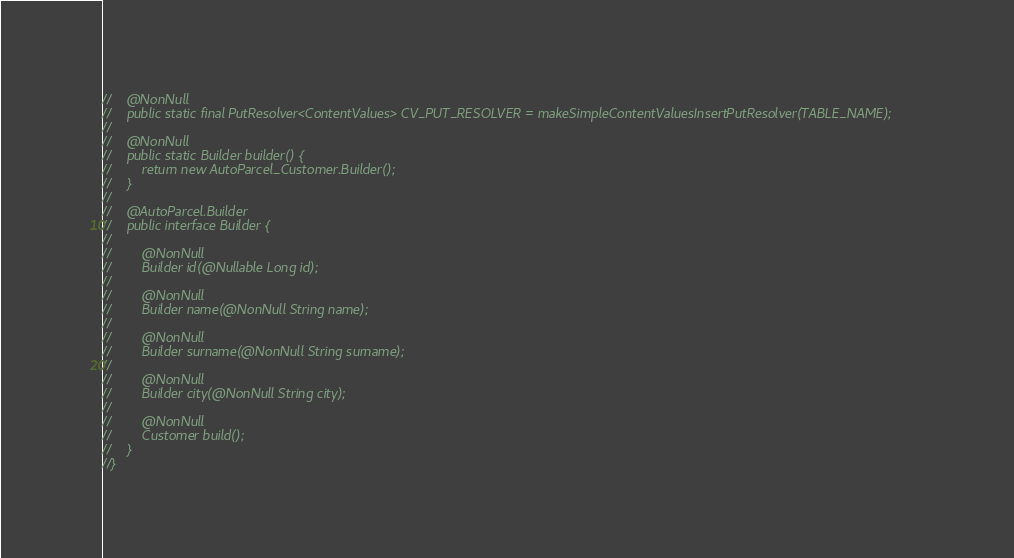Convert code to text. <code><loc_0><loc_0><loc_500><loc_500><_Java_>//    @NonNull
//    public static final PutResolver<ContentValues> CV_PUT_RESOLVER = makeSimpleContentValuesInsertPutResolver(TABLE_NAME);
//
//    @NonNull
//    public static Builder builder() {
//        return new AutoParcel_Customer.Builder();
//    }
//
//    @AutoParcel.Builder
//    public interface Builder {
//
//        @NonNull
//        Builder id(@Nullable Long id);
//
//        @NonNull
//        Builder name(@NonNull String name);
//
//        @NonNull
//        Builder surname(@NonNull String surname);
//
//        @NonNull
//        Builder city(@NonNull String city);
//
//        @NonNull
//        Customer build();
//    }
//}
</code> 